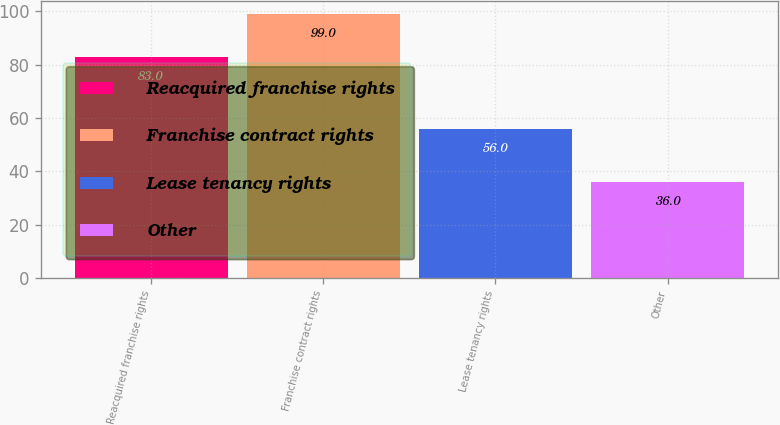Convert chart. <chart><loc_0><loc_0><loc_500><loc_500><bar_chart><fcel>Reacquired franchise rights<fcel>Franchise contract rights<fcel>Lease tenancy rights<fcel>Other<nl><fcel>83<fcel>99<fcel>56<fcel>36<nl></chart> 